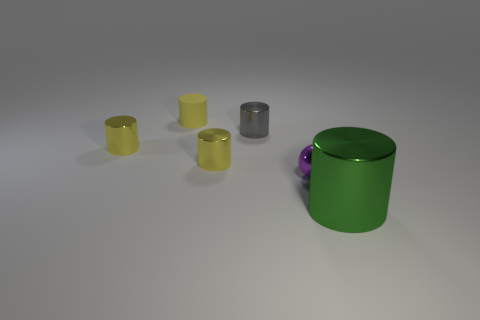What number of other objects are there of the same material as the purple object?
Provide a short and direct response. 4. Are there any tiny metal objects in front of the gray cylinder?
Provide a short and direct response. Yes. There is a ball; is it the same size as the cylinder to the right of the gray metallic cylinder?
Offer a very short reply. No. What is the color of the cylinder that is in front of the small yellow cylinder to the right of the tiny rubber thing?
Your answer should be very brief. Green. Do the metallic sphere and the yellow rubber cylinder have the same size?
Your answer should be compact. Yes. The object that is both right of the gray metal cylinder and behind the green object is what color?
Your answer should be very brief. Purple. The matte object is what size?
Offer a very short reply. Small. There is a small metal object to the left of the matte object; is it the same color as the matte cylinder?
Offer a very short reply. Yes. Is the number of rubber cylinders right of the tiny purple sphere greater than the number of green cylinders that are in front of the green thing?
Make the answer very short. No. Are there more yellow things than red rubber things?
Provide a short and direct response. Yes. 